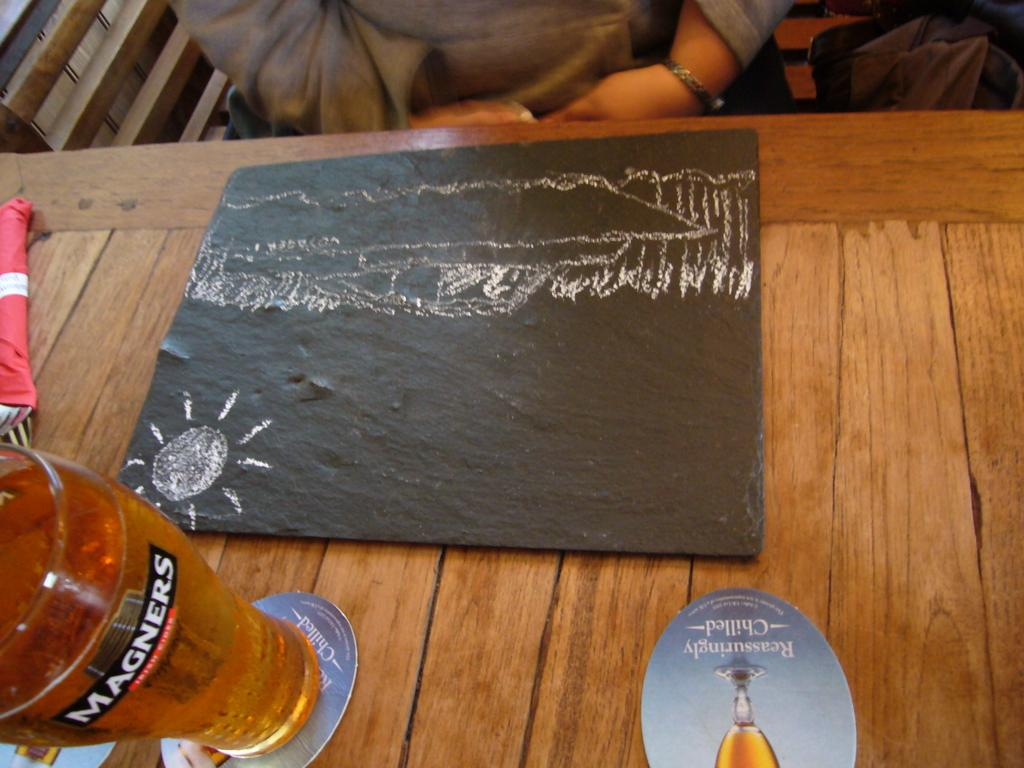<image>
Create a compact narrative representing the image presented. A Chalk Drawing sits next to a Magners glass of beer. 